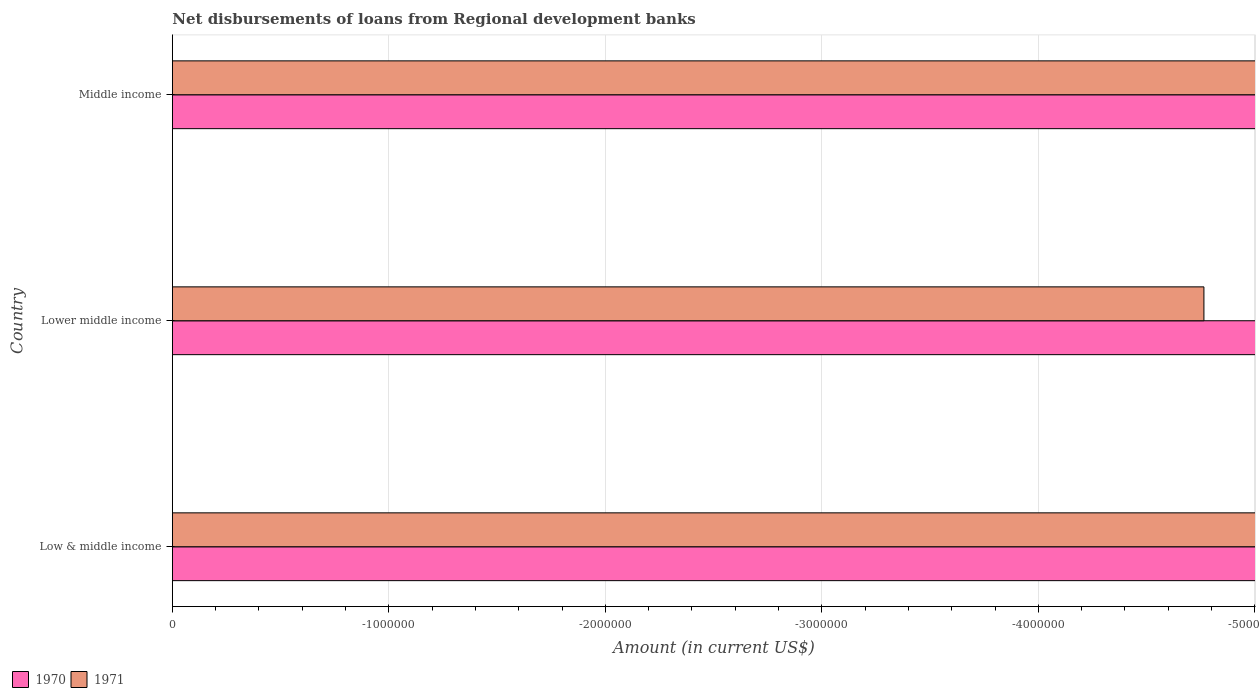How many different coloured bars are there?
Provide a succinct answer. 0. Are the number of bars on each tick of the Y-axis equal?
Your response must be concise. Yes. In how many cases, is the number of bars for a given country not equal to the number of legend labels?
Your answer should be compact. 3. What is the amount of disbursements of loans from regional development banks in 1971 in Low & middle income?
Give a very brief answer. 0. In how many countries, is the amount of disbursements of loans from regional development banks in 1971 greater than -3800000 US$?
Provide a succinct answer. 0. In how many countries, is the amount of disbursements of loans from regional development banks in 1970 greater than the average amount of disbursements of loans from regional development banks in 1970 taken over all countries?
Give a very brief answer. 0. How many countries are there in the graph?
Make the answer very short. 3. Are the values on the major ticks of X-axis written in scientific E-notation?
Give a very brief answer. No. How are the legend labels stacked?
Your answer should be compact. Horizontal. What is the title of the graph?
Ensure brevity in your answer.  Net disbursements of loans from Regional development banks. Does "2002" appear as one of the legend labels in the graph?
Your answer should be compact. No. What is the label or title of the Y-axis?
Your answer should be compact. Country. What is the Amount (in current US$) in 1970 in Low & middle income?
Keep it short and to the point. 0. What is the Amount (in current US$) of 1970 in Middle income?
Your answer should be compact. 0. What is the Amount (in current US$) of 1971 in Middle income?
Offer a terse response. 0. What is the total Amount (in current US$) in 1971 in the graph?
Make the answer very short. 0. 